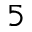Convert formula to latex. <formula><loc_0><loc_0><loc_500><loc_500>5</formula> 